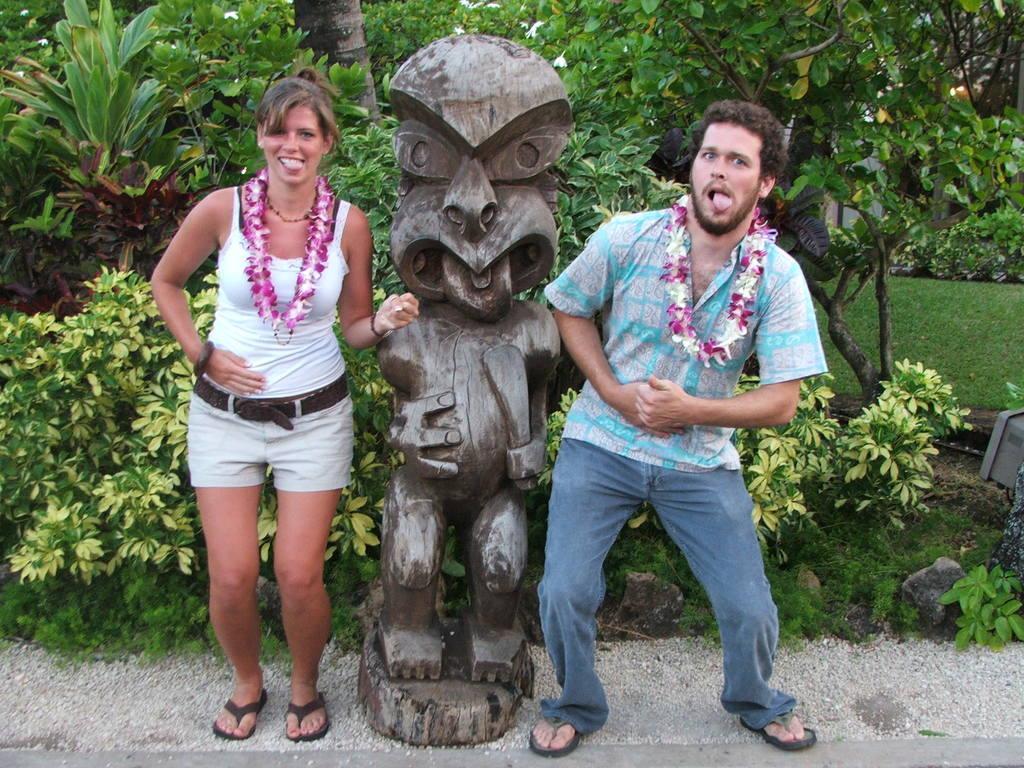In one or two sentences, can you explain what this image depicts? In this picture we can see a man and a woman, there is a statue in the middle, in the background there are some plants, trees and the grass, at the bottom there are some stones. 